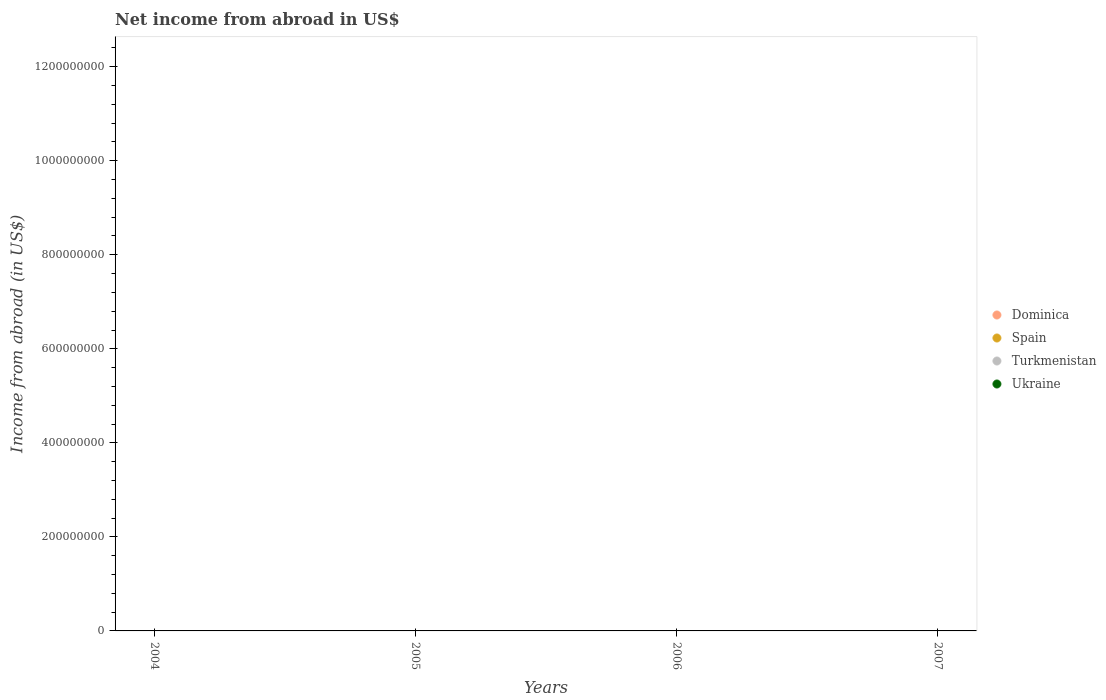What is the net income from abroad in Spain in 2006?
Offer a terse response. 0. What is the total net income from abroad in Turkmenistan in the graph?
Offer a terse response. 0. What is the average net income from abroad in Spain per year?
Offer a terse response. 0. In how many years, is the net income from abroad in Dominica greater than 1000000000 US$?
Provide a short and direct response. 0. In how many years, is the net income from abroad in Dominica greater than the average net income from abroad in Dominica taken over all years?
Your answer should be compact. 0. Is it the case that in every year, the sum of the net income from abroad in Turkmenistan and net income from abroad in Ukraine  is greater than the net income from abroad in Dominica?
Keep it short and to the point. No. Does the graph contain any zero values?
Keep it short and to the point. Yes. Where does the legend appear in the graph?
Keep it short and to the point. Center right. How many legend labels are there?
Keep it short and to the point. 4. How are the legend labels stacked?
Your response must be concise. Vertical. What is the title of the graph?
Keep it short and to the point. Net income from abroad in US$. Does "Colombia" appear as one of the legend labels in the graph?
Offer a very short reply. No. What is the label or title of the Y-axis?
Your answer should be very brief. Income from abroad (in US$). What is the Income from abroad (in US$) in Dominica in 2004?
Keep it short and to the point. 0. What is the Income from abroad (in US$) in Spain in 2005?
Make the answer very short. 0. What is the Income from abroad (in US$) of Turkmenistan in 2005?
Your answer should be very brief. 0. What is the Income from abroad (in US$) of Spain in 2006?
Your answer should be compact. 0. What is the Income from abroad (in US$) of Turkmenistan in 2006?
Ensure brevity in your answer.  0. What is the Income from abroad (in US$) of Spain in 2007?
Offer a terse response. 0. What is the total Income from abroad (in US$) in Dominica in the graph?
Offer a terse response. 0. What is the total Income from abroad (in US$) of Turkmenistan in the graph?
Offer a very short reply. 0. What is the total Income from abroad (in US$) in Ukraine in the graph?
Give a very brief answer. 0. 